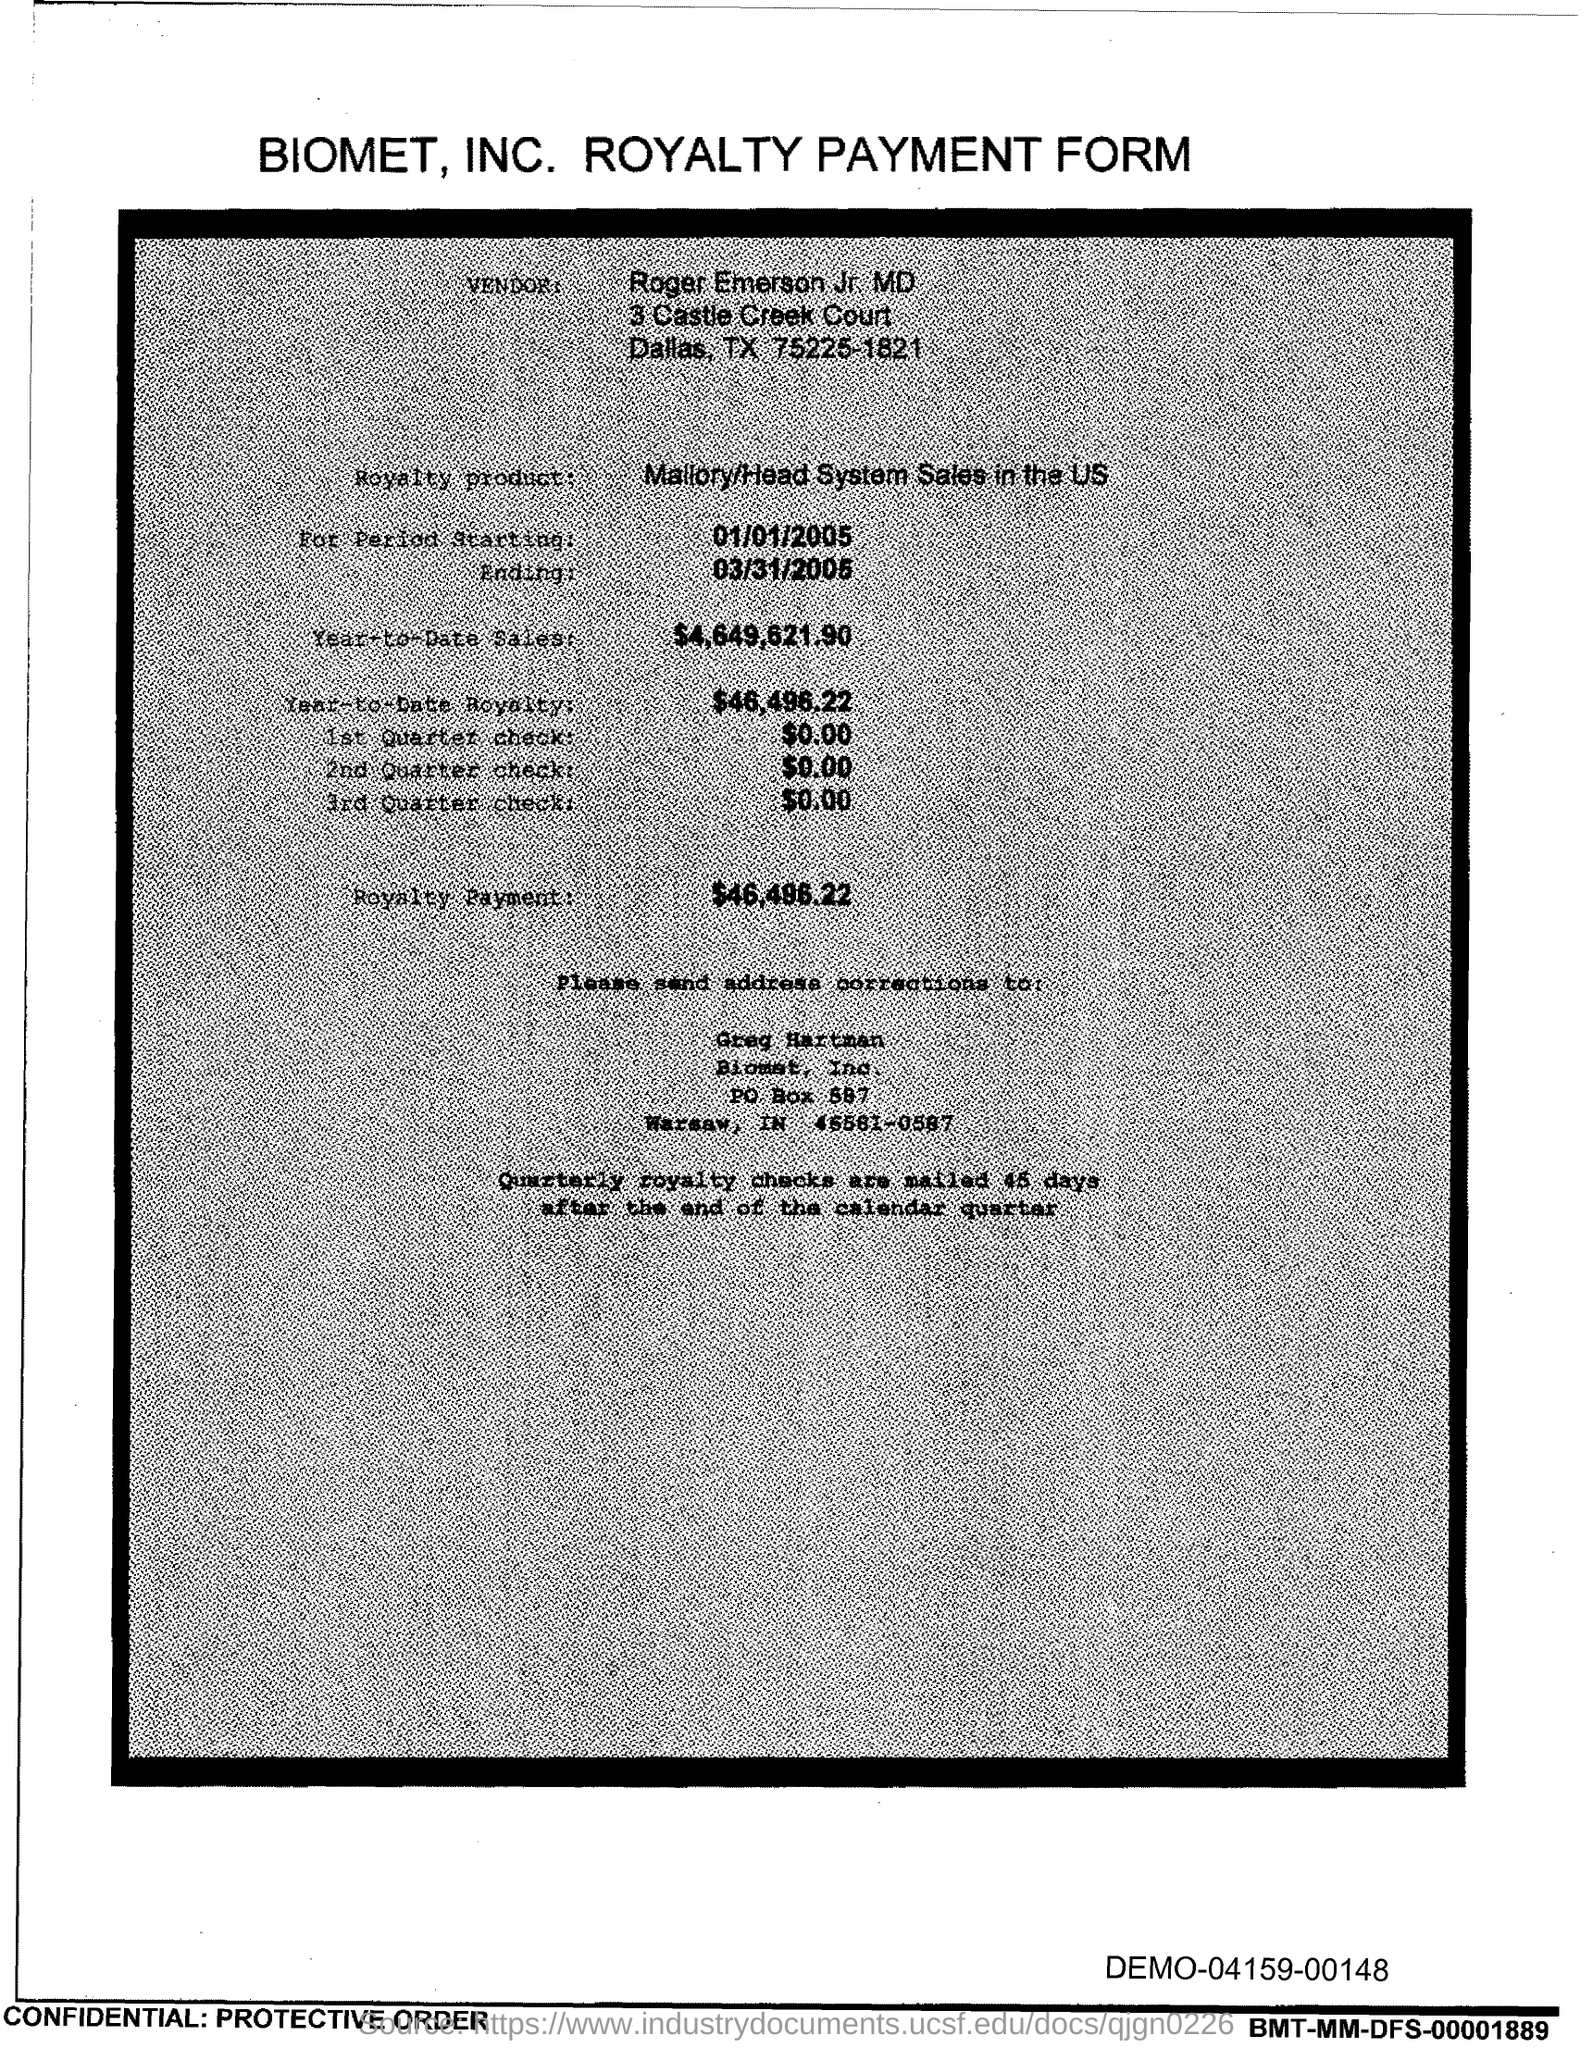Point out several critical features in this image. Roger Emerson Jr., M.D. is the vendor. I'm sorry, I'm not sure what you mean by "Royalty product mentioned?" or "Mallory/Head System Sales in the US.." without any context. Can you please provide me with more information or clarify your question? The correction should be sent to Greg Hartman. This form is about the royalty payment of BIOMET, INC. 